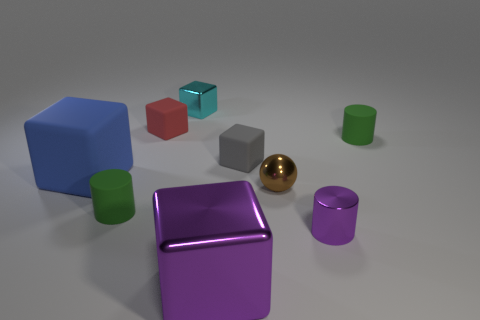There is a small object in front of the small green cylinder left of the small rubber cylinder to the right of the tiny cyan shiny block; what is its shape?
Your response must be concise. Cylinder. The small thing that is both in front of the gray thing and on the left side of the tiny gray matte thing is made of what material?
Keep it short and to the point. Rubber. There is a matte cylinder in front of the rubber block that is on the left side of the tiny green object that is on the left side of the purple metal block; what is its color?
Your response must be concise. Green. What number of yellow things are either large blocks or big rubber cubes?
Give a very brief answer. 0. How many other objects are the same size as the purple cube?
Offer a terse response. 1. How many big blue matte cubes are there?
Your answer should be very brief. 1. Are there any other things that are the same shape as the small purple shiny object?
Provide a succinct answer. Yes. Does the small cube behind the tiny red cube have the same material as the cylinder left of the small cyan cube?
Make the answer very short. No. What is the material of the cyan block?
Make the answer very short. Metal. How many cyan things are made of the same material as the small cyan cube?
Keep it short and to the point. 0. 